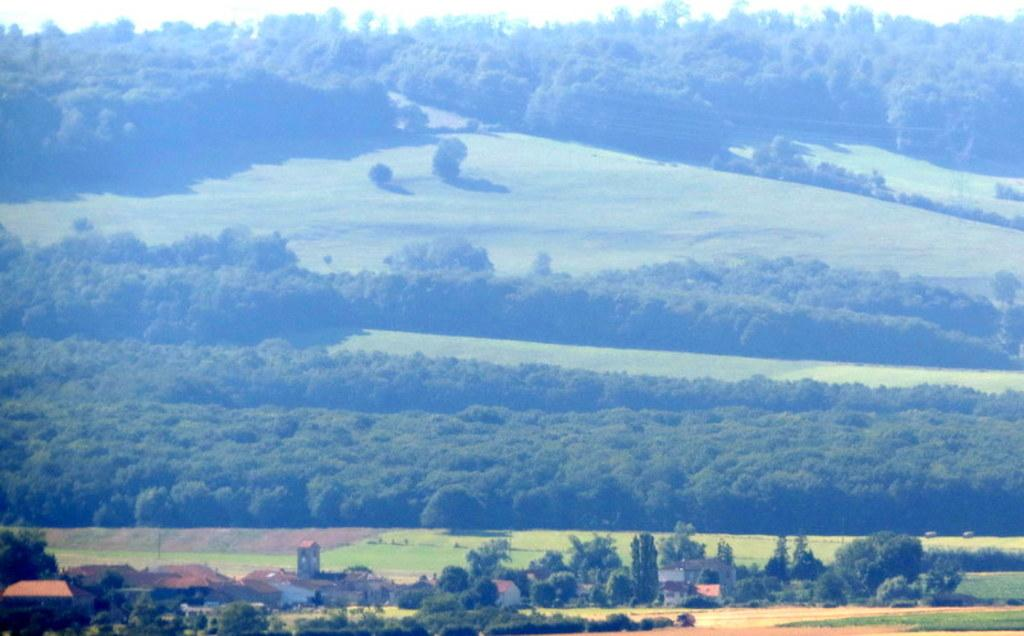What type of structures can be seen in the image? There are houses in the image. What other natural elements are present in the image? There are trees in the image. What part of the natural environment is visible in the image? The sky is visible in the image. Where is the shop located in the image? There is no shop present in the image. What type of comfort can be found in the houses? The image does not provide information about the comfort level inside the houses. 